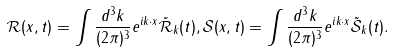Convert formula to latex. <formula><loc_0><loc_0><loc_500><loc_500>\mathcal { R } ( x , t ) = \int \frac { d ^ { 3 } k } { ( 2 \pi ) ^ { 3 } } e ^ { i k \cdot x } \tilde { \mathcal { R } } _ { k } ( t ) , \mathcal { S } ( x , t ) = \int \frac { d ^ { 3 } k } { ( 2 \pi ) ^ { 3 } } e ^ { i k \cdot x } \tilde { \mathcal { S } } _ { k } ( t ) .</formula> 